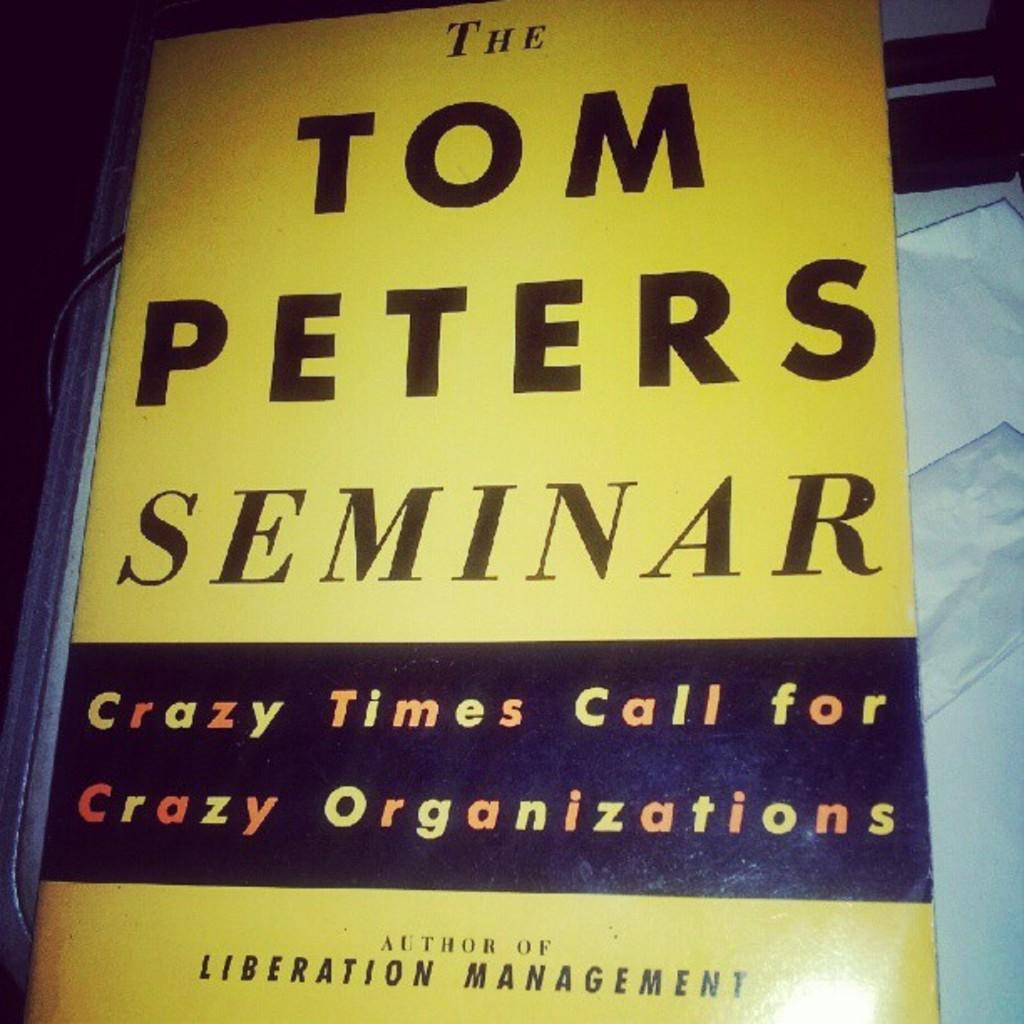<image>
Relay a brief, clear account of the picture shown. A hardcover book called Seminar by Tom Peters 